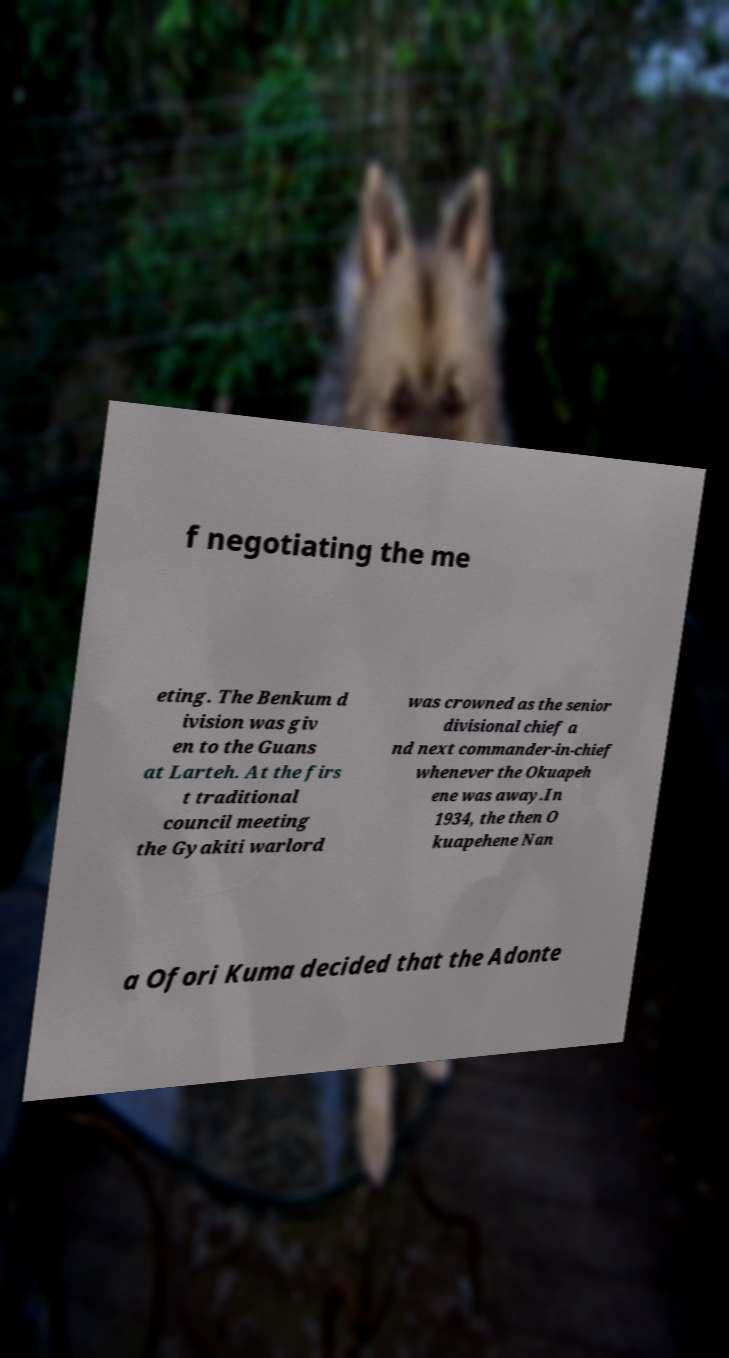For documentation purposes, I need the text within this image transcribed. Could you provide that? f negotiating the me eting. The Benkum d ivision was giv en to the Guans at Larteh. At the firs t traditional council meeting the Gyakiti warlord was crowned as the senior divisional chief a nd next commander-in-chief whenever the Okuapeh ene was away.In 1934, the then O kuapehene Nan a Ofori Kuma decided that the Adonte 